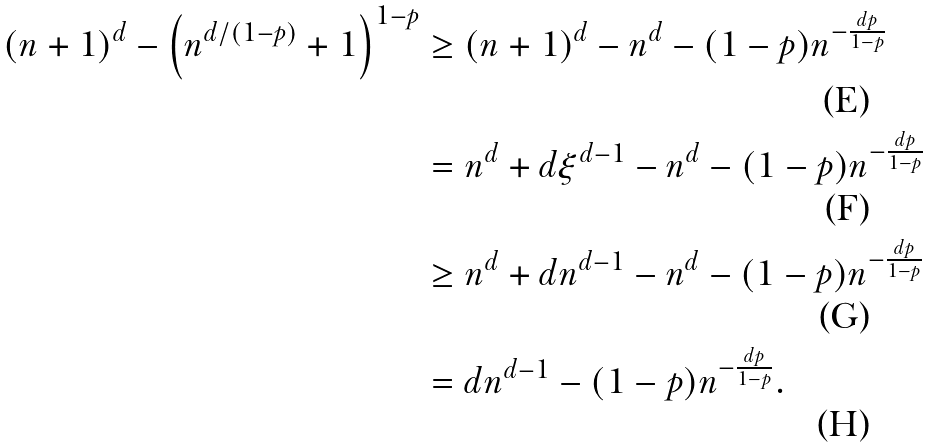<formula> <loc_0><loc_0><loc_500><loc_500>( n + 1 ) ^ { d } - \left ( n ^ { d / ( 1 - p ) } + 1 \right ) ^ { 1 - p } & \geq ( n + 1 ) ^ { d } - n ^ { d } - ( 1 - p ) n ^ { - \frac { d p } { 1 - p } } \\ & = n ^ { d } + d \xi ^ { d - 1 } - n ^ { d } - ( 1 - p ) n ^ { - \frac { d p } { 1 - p } } \\ & \geq n ^ { d } + d n ^ { d - 1 } - n ^ { d } - ( 1 - p ) n ^ { - \frac { d p } { 1 - p } } \\ & = d n ^ { d - 1 } - ( 1 - p ) n ^ { - \frac { d p } { 1 - p } } .</formula> 